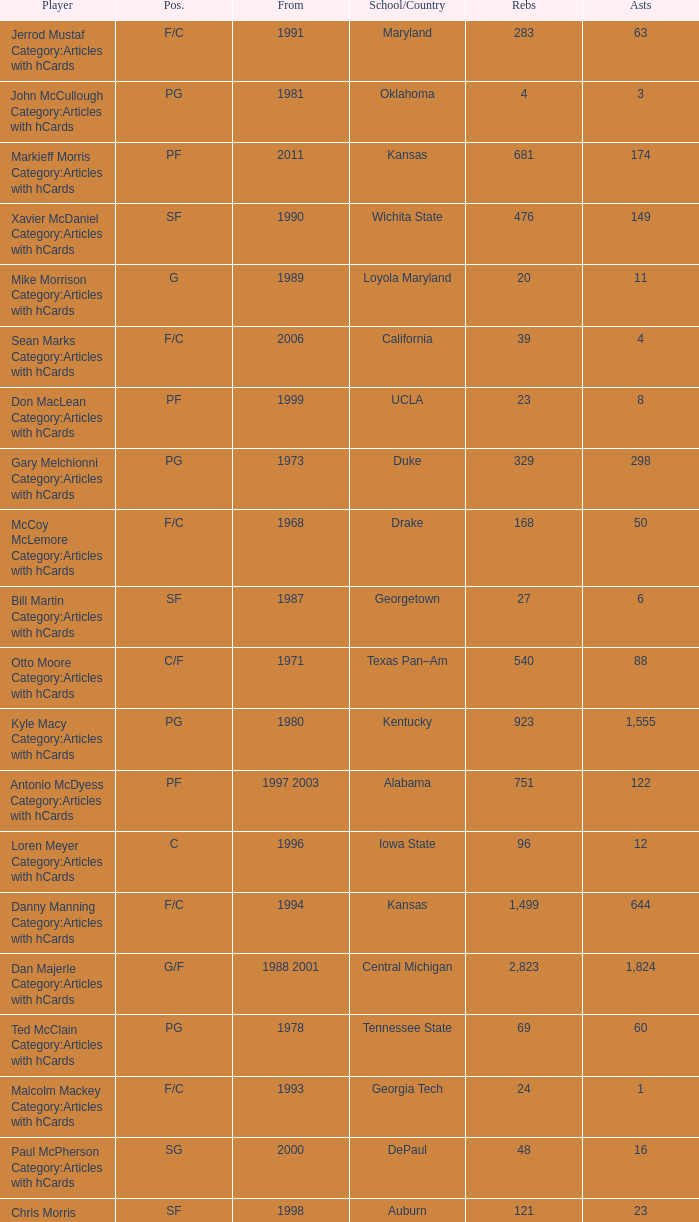Who has the high assists in 2000? 16.0. 